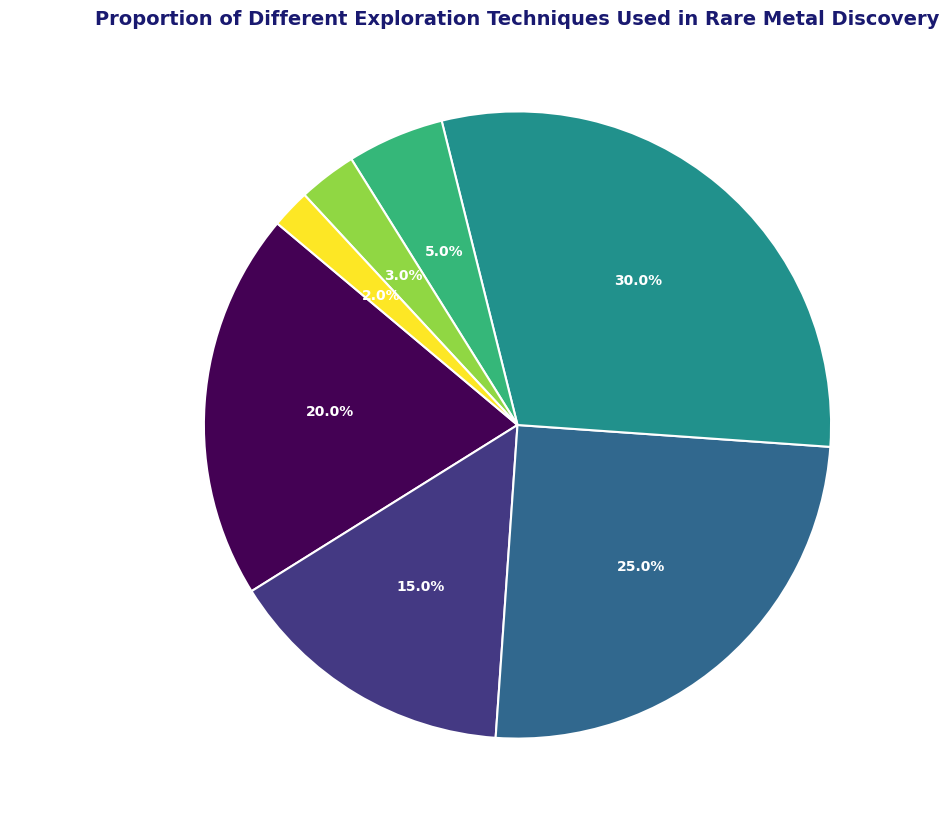What is the proportion of techniques that use surveys? There are three survey techniques: Geochemical Surveys (15%), Geophysical Surveys (25%), and Seismic Surveys (3%). Adding these percentages together gives 15 + 25 + 3 = 43. The combined proportion of survey techniques is 43%.
Answer: 43% Which exploration technique is used the most in rare metal discovery? By observing the pie chart, the largest wedge corresponds to Drilling, which has the highest percentage at 30%.
Answer: Drilling How does the combined proportion of Geological Mapping and Drilling compare to Geophysical Surveys? The combined proportion of Geological Mapping (20%) and Drilling (30%) is 20 + 30 = 50%. Geophysical Surveys have a proportion of 25%. Therefore, 50% (Geological Mapping + Drilling) is greater than 25% (Geophysical Surveys).
Answer: Greater Which technique has the smallest proportion? By observing the smallest wedge in the pie chart, Field Sampling has the smallest proportion at 2%.
Answer: Field Sampling What is the difference in proportion between Remote Sensing and Seismic Surveys? The proportion of Remote Sensing is 5%, and Seismic Surveys is 3%. The difference between them is 5 - 3 = 2%.
Answer: 2% Which exploration techniques together make up more than half of the total proportion? By adding the proportions of individual techniques, Drilling (30%) and Geophysical Surveys (25%) together make 30 + 25 = 55%, which is more than half. Alternatively, Drilling (30%) and Geological Mapping (20%) and Geophysical Surveys (25%) together make 30 + 20 + 25 = 75%. So, two possible groups: Drilling + Geophysical Surveys, or Drilling + Geological Mapping + Geophysical Surveys.
Answer: Drilling and Geophysical Surveys What proportion remains after excluding Geophysical Surveys and Drilling? The remaining techniques are Geological Mapping (20%), Geochemical Surveys (15%), Remote Sensing (5%), Seismic Surveys (3%), and Field Sampling (2%). Summing these gives 20 + 15 + 5 + 3 + 2 = 45%.
Answer: 45% What is the visual attribute representing Drilling in the pie chart, such as wedge size and text color? The Drilling section appears as the largest wedge in the pie chart. The label text is displayed in white color on the chart as specified for all textprops.
Answer: Largest wedge, white text 